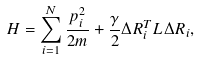Convert formula to latex. <formula><loc_0><loc_0><loc_500><loc_500>H = \sum _ { i = 1 } ^ { N } \frac { p _ { i } ^ { 2 } } { 2 m } + \frac { \gamma } { 2 } \Delta R _ { i } ^ { T } L \Delta R _ { i } ,</formula> 